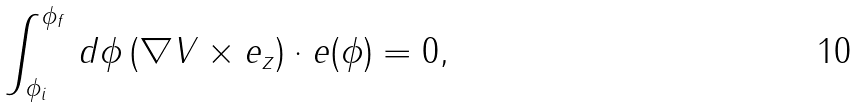<formula> <loc_0><loc_0><loc_500><loc_500>\int _ { \phi _ { i } } ^ { \phi _ { f } } \, d \phi \, ( \nabla V \times { e } _ { z } ) \cdot { e ( \phi ) } = 0 ,</formula> 